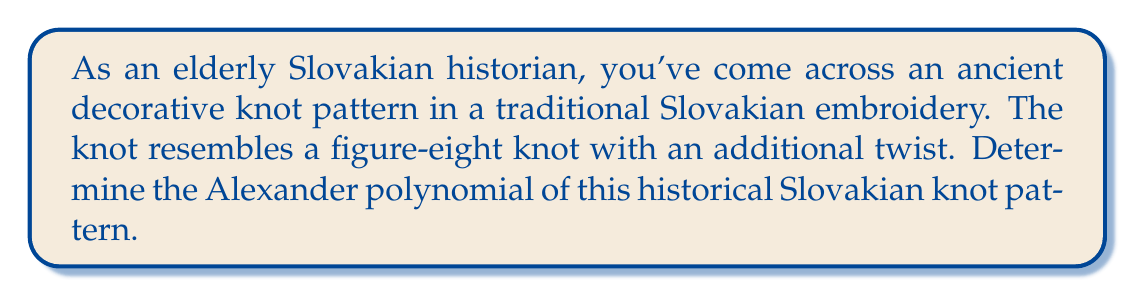Teach me how to tackle this problem. To determine the Alexander polynomial of this historical Slovakian knot pattern, we'll follow these steps:

1. Identify the knot: The description suggests a variation of the figure-eight knot with an additional twist. This knot is known as the 5_2 knot in knot theory.

2. Draw the knot diagram:
[asy]
import geometry;

path p = (0,0)--(1,1)--(2,0)--(1,-1)--cycle;
path q = (1,1)--(2,2)--(3,1)--(2,0);
path r = (1,-1)--(2,-2)--(3,-1)--(2,0);

draw(p);
draw(q);
draw(r);

draw((2,0)--(3,1), dashed);
draw((2,0)--(3,-1), dashed);
[/asy]

3. Label the arcs and crossings:
[asy]
import geometry;

path p = (0,0)--(1,1)--(2,0)--(1,-1)--cycle;
path q = (1,1)--(2,2)--(3,1)--(2,0);
path r = (1,-1)--(2,-2)--(3,-1)--(2,0);

draw(p);
draw(q);
draw(r);

draw((2,0)--(3,1), dashed);
draw((2,0)--(3,-1), dashed);

label("a", (0.5,0.5), NW);
label("b", (2.5,1.5), NE);
label("c", (2.5,-1.5), SE);
label("d", (1.5,0), E);
label("e", (0.5,-0.5), SW);

label("1", (1,1), NW);
label("2", (2,0), N);
label("3", (1,-1), SW);
label("4", (2,2), NE);
label("5", (2,-2), SE);
[/asy]

4. Create the Alexander matrix:
The Alexander matrix for this knot is:

$$
\begin{pmatrix}
1-t & -1 & 0 & t & 0 \\
0 & 1-t & -1 & 0 & t \\
t & 0 & 1-t & -1 & 0 \\
-1 & t & 0 & 1-t & 0 \\
0 & -1 & t & 0 & 1-t
\end{pmatrix}
$$

5. Calculate the determinant of any 4x4 minor of this matrix. Let's choose the minor obtained by removing the last row and column:

$$
\det \begin{pmatrix}
1-t & -1 & 0 & t \\
0 & 1-t & -1 & 0 \\
t & 0 & 1-t & -1 \\
-1 & t & 0 & 1-t
\end{pmatrix}
$$

6. Expand the determinant:

$$(1-t)((1-t)((1-t)(1-t) + t) + t) + t(t(1-t) + (1-t))$$

7. Simplify:

$$1 - t + t^2 - 2t^3 + t^4$$

8. Normalize the polynomial by ensuring the lowest degree term is positive and the highest degree term has a positive coefficient:

$$t^4 - 2t^3 + t^2 - t + 1$$

This is the Alexander polynomial of the 5_2 knot, which matches our historical Slovakian knot pattern.
Answer: $t^4 - 2t^3 + t^2 - t + 1$ 